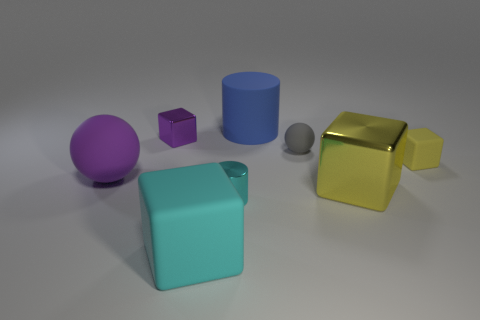There is a large object in front of the small cyan metallic cylinder right of the big cyan matte thing; what is its shape?
Keep it short and to the point. Cube. What number of purple shiny balls are the same size as the matte cylinder?
Provide a succinct answer. 0. Are any big yellow matte balls visible?
Your answer should be very brief. No. Is there anything else that has the same color as the small metal cylinder?
Ensure brevity in your answer.  Yes. What shape is the tiny purple object that is the same material as the small cylinder?
Provide a short and direct response. Cube. What color is the large object that is behind the big rubber object that is to the left of the metallic object behind the big purple object?
Ensure brevity in your answer.  Blue. Is the number of large yellow blocks that are behind the tiny shiny block the same as the number of tiny gray things?
Provide a short and direct response. No. Does the metallic cylinder have the same color as the large object in front of the large yellow cube?
Provide a short and direct response. Yes. There is a purple object that is in front of the tiny thing behind the tiny gray ball; are there any tiny things that are behind it?
Give a very brief answer. Yes. Are there fewer tiny shiny cylinders to the left of the shiny cylinder than matte objects?
Offer a very short reply. Yes. 